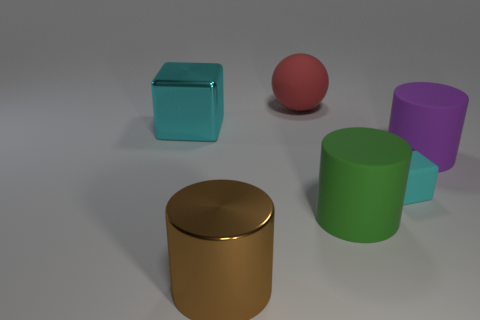Are there any other things that are the same size as the cyan matte object?
Keep it short and to the point. No. Are there any other things that are the same shape as the red thing?
Give a very brief answer. No. There is another object that is made of the same material as the big brown object; what color is it?
Provide a short and direct response. Cyan. Are there an equal number of red spheres in front of the large shiny cylinder and large purple rubber cylinders?
Provide a short and direct response. No. There is a rubber cylinder that is to the right of the green object; is its size the same as the cyan metal object?
Ensure brevity in your answer.  Yes. There is a ball that is the same size as the cyan metal object; what is its color?
Offer a very short reply. Red. Are there any cubes right of the cyan thing that is left of the large metal object in front of the cyan metal object?
Provide a succinct answer. Yes. There is a cube on the left side of the green cylinder; what is its material?
Your response must be concise. Metal. There is a cyan metal object; is its shape the same as the cyan thing to the right of the sphere?
Offer a very short reply. Yes. Is the number of cyan shiny things behind the brown cylinder the same as the number of cyan cubes that are in front of the large cube?
Offer a terse response. Yes. 